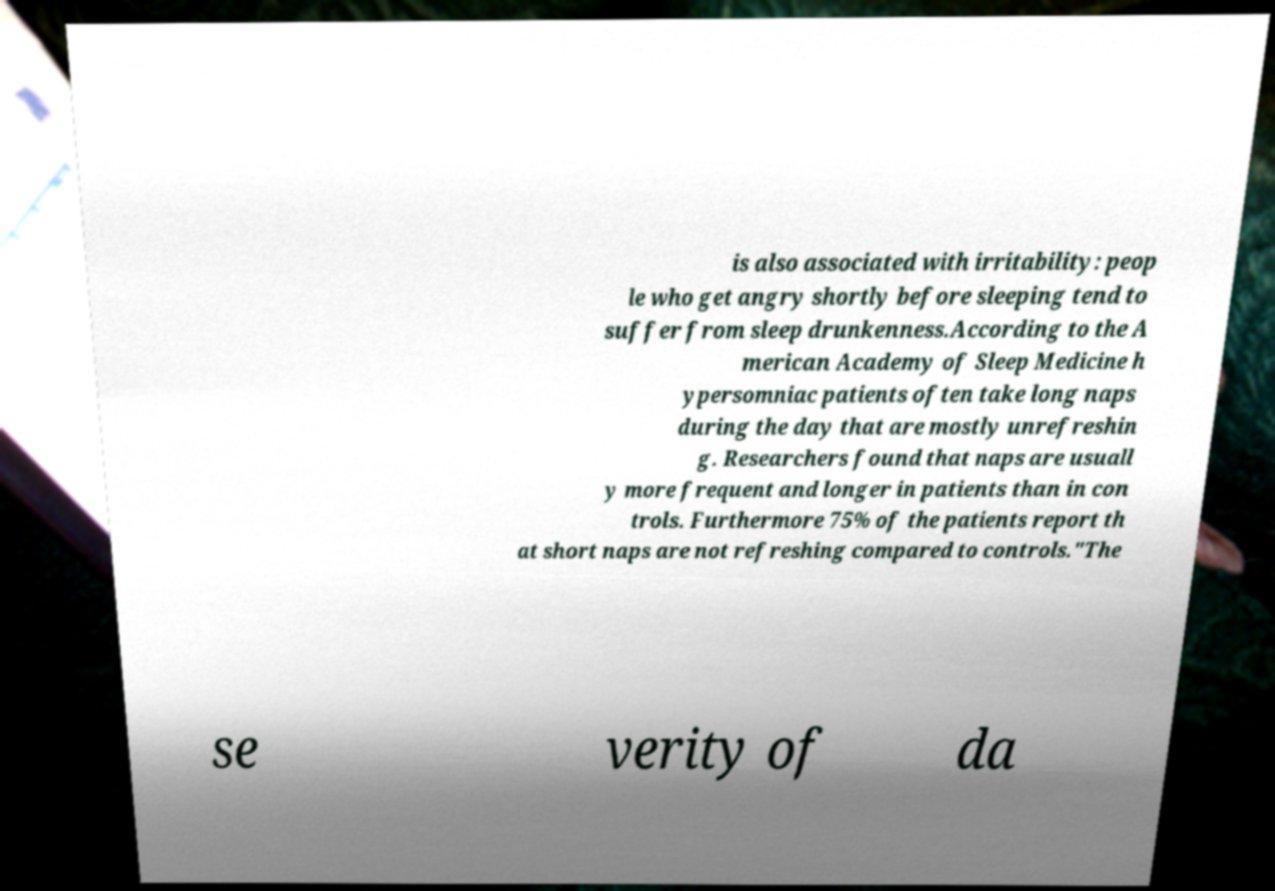What messages or text are displayed in this image? I need them in a readable, typed format. is also associated with irritability: peop le who get angry shortly before sleeping tend to suffer from sleep drunkenness.According to the A merican Academy of Sleep Medicine h ypersomniac patients often take long naps during the day that are mostly unrefreshin g. Researchers found that naps are usuall y more frequent and longer in patients than in con trols. Furthermore 75% of the patients report th at short naps are not refreshing compared to controls."The se verity of da 